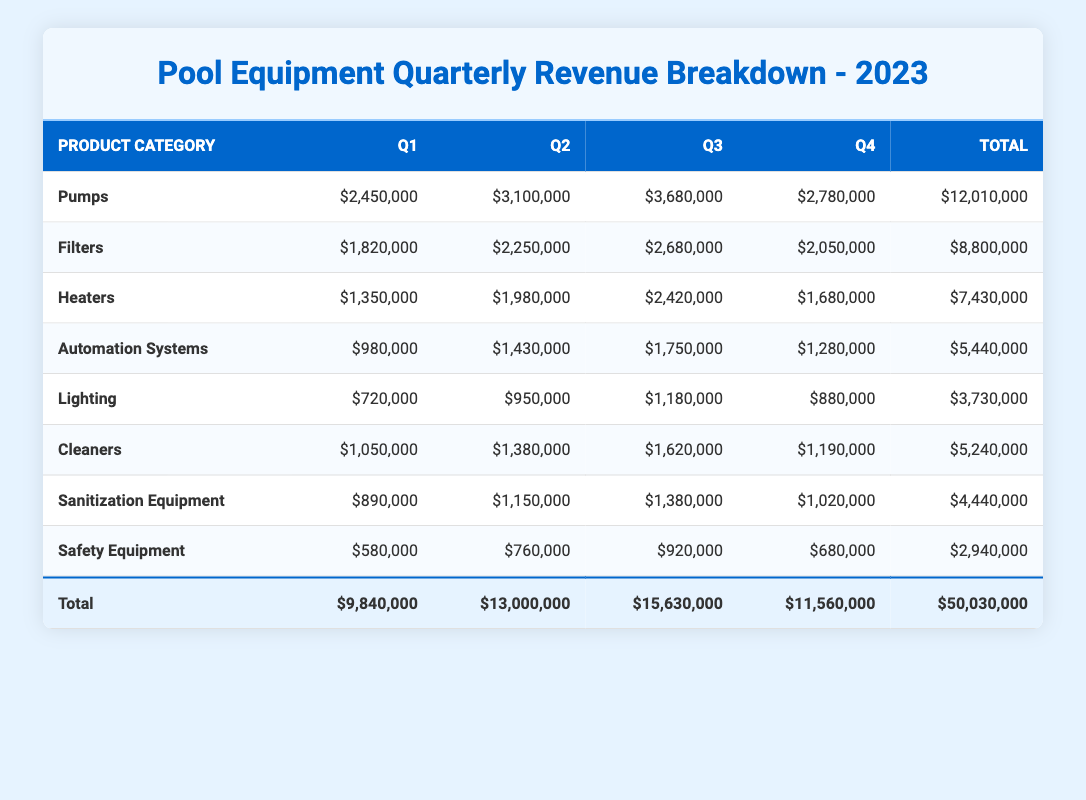What was the total revenue from Pumps in 2023? The total revenue from Pumps is found by summing the quarterly revenues: 2,450,000 + 3,100,000 + 3,680,000 + 2,780,000 = 12,010,000.
Answer: 12,010,000 Which product category had the highest quarterly revenue in Q3? To find the highest revenue in Q3, we compare the revenue values: Pumps (3,680,000), Filters (2,680,000), Heaters (2,420,000), Automation Systems (1,750,000), Lighting (1,180,000), Cleaners (1,620,000), Sanitization Equipment (1,380,000), Safety Equipment (920,000). The highest is Pumps at 3,680,000.
Answer: Pumps Did Lighting generate more revenue than Safety Equipment in Q4? In Q4, Lighting had a revenue of 880,000 while Safety Equipment had 680,000. Since 880,000 is greater than 680,000, the statement is true.
Answer: Yes What is the average revenue for Filters across all quarters? To calculate the average revenue for Filters, sum the quarterly revenues: 1,820,000 + 2,250,000 + 2,680,000 + 2,050,000 = 8,800,000. There are 4 quarters, so the average is 8,800,000 / 4 = 2,200,000.
Answer: 2,200,000 Which product category had the lowest total revenue for the year? We start by determining the total revenue for each category: Pumps (12,010,000), Filters (8,800,000), Heaters (7,430,000), Automation Systems (5,440,000), Lighting (3,730,000), Cleaners (5,240,000), Sanitization Equipment (4,440,000), Safety Equipment (2,940,000). The lowest total is Safety Equipment with 2,940,000.
Answer: Safety Equipment What was the total revenue for Q2 across all product categories? To find the total revenue for Q2, we sum the revenues for each category in that quarter: 3,100,000 (Pumps) + 2,250,000 (Filters) + 1,980,000 (Heaters) + 1,430,000 (Automation Systems) + 950,000 (Lighting) + 1,380,000 (Cleaners) + 1,150,000 (Sanitization Equipment) + 760,000 (Safety Equipment) = 13,000,000.
Answer: 13,000,000 Was the revenue from Heaters in Q1 higher than the revenue from Cleaners in Q4? Heaters generated 1,350,000 in Q1, and Cleaners earned 1,190,000 in Q4. Comparing both values, 1,350,000 is greater than 1,190,000, so the statement is true.
Answer: Yes How much more revenue did Automation Systems generate in Q3 compared to Q1? The revenue for Automation Systems in Q3 is 1,750,000 and in Q1 is 980,000. To find the difference, we subtract Q1 from Q3: 1,750,000 - 980,000 = 770,000.
Answer: 770,000 